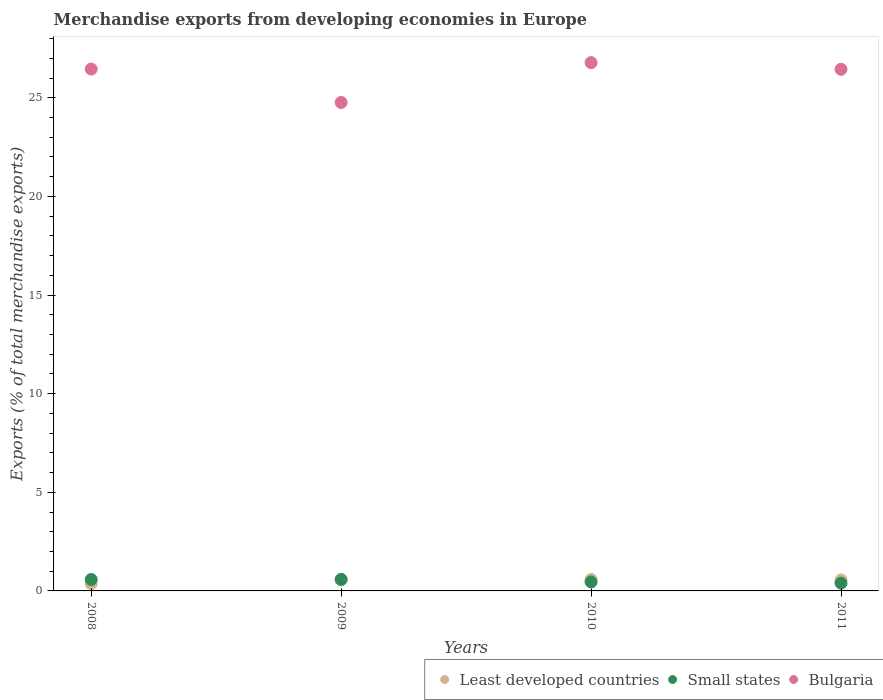How many different coloured dotlines are there?
Offer a very short reply. 3. What is the percentage of total merchandise exports in Small states in 2009?
Provide a short and direct response. 0.58. Across all years, what is the maximum percentage of total merchandise exports in Small states?
Offer a very short reply. 0.58. Across all years, what is the minimum percentage of total merchandise exports in Small states?
Ensure brevity in your answer.  0.39. In which year was the percentage of total merchandise exports in Least developed countries maximum?
Your response must be concise. 2010. In which year was the percentage of total merchandise exports in Bulgaria minimum?
Your answer should be very brief. 2009. What is the total percentage of total merchandise exports in Small states in the graph?
Your answer should be compact. 2.01. What is the difference between the percentage of total merchandise exports in Small states in 2009 and that in 2010?
Ensure brevity in your answer.  0.13. What is the difference between the percentage of total merchandise exports in Small states in 2008 and the percentage of total merchandise exports in Bulgaria in 2010?
Offer a very short reply. -26.2. What is the average percentage of total merchandise exports in Least developed countries per year?
Make the answer very short. 0.52. In the year 2009, what is the difference between the percentage of total merchandise exports in Bulgaria and percentage of total merchandise exports in Small states?
Provide a short and direct response. 24.18. What is the ratio of the percentage of total merchandise exports in Least developed countries in 2009 to that in 2011?
Make the answer very short. 1.02. What is the difference between the highest and the second highest percentage of total merchandise exports in Small states?
Make the answer very short. 0. What is the difference between the highest and the lowest percentage of total merchandise exports in Bulgaria?
Your answer should be very brief. 2.02. Is the sum of the percentage of total merchandise exports in Small states in 2009 and 2010 greater than the maximum percentage of total merchandise exports in Bulgaria across all years?
Your response must be concise. No. Is the percentage of total merchandise exports in Small states strictly greater than the percentage of total merchandise exports in Least developed countries over the years?
Your answer should be compact. No. How many years are there in the graph?
Offer a very short reply. 4. What is the difference between two consecutive major ticks on the Y-axis?
Give a very brief answer. 5. Are the values on the major ticks of Y-axis written in scientific E-notation?
Ensure brevity in your answer.  No. Where does the legend appear in the graph?
Ensure brevity in your answer.  Bottom right. How many legend labels are there?
Offer a very short reply. 3. How are the legend labels stacked?
Offer a very short reply. Horizontal. What is the title of the graph?
Offer a terse response. Merchandise exports from developing economies in Europe. What is the label or title of the Y-axis?
Your response must be concise. Exports (% of total merchandise exports). What is the Exports (% of total merchandise exports) of Least developed countries in 2008?
Your answer should be very brief. 0.37. What is the Exports (% of total merchandise exports) of Small states in 2008?
Make the answer very short. 0.58. What is the Exports (% of total merchandise exports) in Bulgaria in 2008?
Your answer should be very brief. 26.46. What is the Exports (% of total merchandise exports) in Least developed countries in 2009?
Your response must be concise. 0.57. What is the Exports (% of total merchandise exports) in Small states in 2009?
Provide a short and direct response. 0.58. What is the Exports (% of total merchandise exports) in Bulgaria in 2009?
Ensure brevity in your answer.  24.76. What is the Exports (% of total merchandise exports) in Least developed countries in 2010?
Your response must be concise. 0.58. What is the Exports (% of total merchandise exports) in Small states in 2010?
Make the answer very short. 0.46. What is the Exports (% of total merchandise exports) in Bulgaria in 2010?
Keep it short and to the point. 26.78. What is the Exports (% of total merchandise exports) of Least developed countries in 2011?
Make the answer very short. 0.56. What is the Exports (% of total merchandise exports) in Small states in 2011?
Your answer should be very brief. 0.39. What is the Exports (% of total merchandise exports) in Bulgaria in 2011?
Offer a very short reply. 26.44. Across all years, what is the maximum Exports (% of total merchandise exports) in Least developed countries?
Your answer should be compact. 0.58. Across all years, what is the maximum Exports (% of total merchandise exports) of Small states?
Offer a terse response. 0.58. Across all years, what is the maximum Exports (% of total merchandise exports) of Bulgaria?
Offer a very short reply. 26.78. Across all years, what is the minimum Exports (% of total merchandise exports) of Least developed countries?
Your response must be concise. 0.37. Across all years, what is the minimum Exports (% of total merchandise exports) of Small states?
Give a very brief answer. 0.39. Across all years, what is the minimum Exports (% of total merchandise exports) of Bulgaria?
Offer a terse response. 24.76. What is the total Exports (% of total merchandise exports) of Least developed countries in the graph?
Provide a succinct answer. 2.07. What is the total Exports (% of total merchandise exports) of Small states in the graph?
Offer a very short reply. 2.01. What is the total Exports (% of total merchandise exports) of Bulgaria in the graph?
Provide a succinct answer. 104.44. What is the difference between the Exports (% of total merchandise exports) in Least developed countries in 2008 and that in 2009?
Ensure brevity in your answer.  -0.2. What is the difference between the Exports (% of total merchandise exports) in Small states in 2008 and that in 2009?
Your answer should be very brief. -0. What is the difference between the Exports (% of total merchandise exports) in Bulgaria in 2008 and that in 2009?
Ensure brevity in your answer.  1.69. What is the difference between the Exports (% of total merchandise exports) in Least developed countries in 2008 and that in 2010?
Offer a very short reply. -0.21. What is the difference between the Exports (% of total merchandise exports) of Small states in 2008 and that in 2010?
Your answer should be compact. 0.12. What is the difference between the Exports (% of total merchandise exports) in Bulgaria in 2008 and that in 2010?
Offer a very short reply. -0.33. What is the difference between the Exports (% of total merchandise exports) in Least developed countries in 2008 and that in 2011?
Provide a short and direct response. -0.19. What is the difference between the Exports (% of total merchandise exports) of Small states in 2008 and that in 2011?
Your response must be concise. 0.18. What is the difference between the Exports (% of total merchandise exports) of Bulgaria in 2008 and that in 2011?
Ensure brevity in your answer.  0.01. What is the difference between the Exports (% of total merchandise exports) in Least developed countries in 2009 and that in 2010?
Keep it short and to the point. -0.01. What is the difference between the Exports (% of total merchandise exports) of Small states in 2009 and that in 2010?
Your response must be concise. 0.13. What is the difference between the Exports (% of total merchandise exports) of Bulgaria in 2009 and that in 2010?
Give a very brief answer. -2.02. What is the difference between the Exports (% of total merchandise exports) of Least developed countries in 2009 and that in 2011?
Provide a short and direct response. 0.01. What is the difference between the Exports (% of total merchandise exports) of Small states in 2009 and that in 2011?
Ensure brevity in your answer.  0.19. What is the difference between the Exports (% of total merchandise exports) in Bulgaria in 2009 and that in 2011?
Ensure brevity in your answer.  -1.68. What is the difference between the Exports (% of total merchandise exports) of Least developed countries in 2010 and that in 2011?
Your answer should be compact. 0.02. What is the difference between the Exports (% of total merchandise exports) in Small states in 2010 and that in 2011?
Give a very brief answer. 0.06. What is the difference between the Exports (% of total merchandise exports) in Bulgaria in 2010 and that in 2011?
Give a very brief answer. 0.34. What is the difference between the Exports (% of total merchandise exports) in Least developed countries in 2008 and the Exports (% of total merchandise exports) in Small states in 2009?
Provide a succinct answer. -0.22. What is the difference between the Exports (% of total merchandise exports) in Least developed countries in 2008 and the Exports (% of total merchandise exports) in Bulgaria in 2009?
Keep it short and to the point. -24.4. What is the difference between the Exports (% of total merchandise exports) of Small states in 2008 and the Exports (% of total merchandise exports) of Bulgaria in 2009?
Give a very brief answer. -24.18. What is the difference between the Exports (% of total merchandise exports) in Least developed countries in 2008 and the Exports (% of total merchandise exports) in Small states in 2010?
Ensure brevity in your answer.  -0.09. What is the difference between the Exports (% of total merchandise exports) in Least developed countries in 2008 and the Exports (% of total merchandise exports) in Bulgaria in 2010?
Keep it short and to the point. -26.41. What is the difference between the Exports (% of total merchandise exports) in Small states in 2008 and the Exports (% of total merchandise exports) in Bulgaria in 2010?
Offer a terse response. -26.2. What is the difference between the Exports (% of total merchandise exports) in Least developed countries in 2008 and the Exports (% of total merchandise exports) in Small states in 2011?
Offer a terse response. -0.03. What is the difference between the Exports (% of total merchandise exports) in Least developed countries in 2008 and the Exports (% of total merchandise exports) in Bulgaria in 2011?
Keep it short and to the point. -26.08. What is the difference between the Exports (% of total merchandise exports) in Small states in 2008 and the Exports (% of total merchandise exports) in Bulgaria in 2011?
Your answer should be compact. -25.87. What is the difference between the Exports (% of total merchandise exports) of Least developed countries in 2009 and the Exports (% of total merchandise exports) of Small states in 2010?
Your response must be concise. 0.11. What is the difference between the Exports (% of total merchandise exports) of Least developed countries in 2009 and the Exports (% of total merchandise exports) of Bulgaria in 2010?
Your answer should be compact. -26.21. What is the difference between the Exports (% of total merchandise exports) in Small states in 2009 and the Exports (% of total merchandise exports) in Bulgaria in 2010?
Provide a succinct answer. -26.2. What is the difference between the Exports (% of total merchandise exports) of Least developed countries in 2009 and the Exports (% of total merchandise exports) of Small states in 2011?
Offer a very short reply. 0.17. What is the difference between the Exports (% of total merchandise exports) of Least developed countries in 2009 and the Exports (% of total merchandise exports) of Bulgaria in 2011?
Offer a very short reply. -25.88. What is the difference between the Exports (% of total merchandise exports) in Small states in 2009 and the Exports (% of total merchandise exports) in Bulgaria in 2011?
Keep it short and to the point. -25.86. What is the difference between the Exports (% of total merchandise exports) of Least developed countries in 2010 and the Exports (% of total merchandise exports) of Small states in 2011?
Offer a very short reply. 0.18. What is the difference between the Exports (% of total merchandise exports) in Least developed countries in 2010 and the Exports (% of total merchandise exports) in Bulgaria in 2011?
Keep it short and to the point. -25.87. What is the difference between the Exports (% of total merchandise exports) of Small states in 2010 and the Exports (% of total merchandise exports) of Bulgaria in 2011?
Offer a terse response. -25.99. What is the average Exports (% of total merchandise exports) of Least developed countries per year?
Provide a short and direct response. 0.52. What is the average Exports (% of total merchandise exports) of Small states per year?
Provide a succinct answer. 0.5. What is the average Exports (% of total merchandise exports) of Bulgaria per year?
Give a very brief answer. 26.11. In the year 2008, what is the difference between the Exports (% of total merchandise exports) in Least developed countries and Exports (% of total merchandise exports) in Small states?
Give a very brief answer. -0.21. In the year 2008, what is the difference between the Exports (% of total merchandise exports) in Least developed countries and Exports (% of total merchandise exports) in Bulgaria?
Offer a terse response. -26.09. In the year 2008, what is the difference between the Exports (% of total merchandise exports) of Small states and Exports (% of total merchandise exports) of Bulgaria?
Your answer should be compact. -25.88. In the year 2009, what is the difference between the Exports (% of total merchandise exports) of Least developed countries and Exports (% of total merchandise exports) of Small states?
Give a very brief answer. -0.01. In the year 2009, what is the difference between the Exports (% of total merchandise exports) in Least developed countries and Exports (% of total merchandise exports) in Bulgaria?
Make the answer very short. -24.19. In the year 2009, what is the difference between the Exports (% of total merchandise exports) in Small states and Exports (% of total merchandise exports) in Bulgaria?
Your response must be concise. -24.18. In the year 2010, what is the difference between the Exports (% of total merchandise exports) in Least developed countries and Exports (% of total merchandise exports) in Small states?
Provide a short and direct response. 0.12. In the year 2010, what is the difference between the Exports (% of total merchandise exports) of Least developed countries and Exports (% of total merchandise exports) of Bulgaria?
Offer a very short reply. -26.2. In the year 2010, what is the difference between the Exports (% of total merchandise exports) of Small states and Exports (% of total merchandise exports) of Bulgaria?
Offer a very short reply. -26.33. In the year 2011, what is the difference between the Exports (% of total merchandise exports) of Least developed countries and Exports (% of total merchandise exports) of Small states?
Offer a terse response. 0.16. In the year 2011, what is the difference between the Exports (% of total merchandise exports) of Least developed countries and Exports (% of total merchandise exports) of Bulgaria?
Your answer should be very brief. -25.89. In the year 2011, what is the difference between the Exports (% of total merchandise exports) of Small states and Exports (% of total merchandise exports) of Bulgaria?
Give a very brief answer. -26.05. What is the ratio of the Exports (% of total merchandise exports) of Least developed countries in 2008 to that in 2009?
Your answer should be very brief. 0.64. What is the ratio of the Exports (% of total merchandise exports) in Small states in 2008 to that in 2009?
Ensure brevity in your answer.  0.99. What is the ratio of the Exports (% of total merchandise exports) in Bulgaria in 2008 to that in 2009?
Make the answer very short. 1.07. What is the ratio of the Exports (% of total merchandise exports) in Least developed countries in 2008 to that in 2010?
Offer a terse response. 0.63. What is the ratio of the Exports (% of total merchandise exports) in Small states in 2008 to that in 2010?
Make the answer very short. 1.27. What is the ratio of the Exports (% of total merchandise exports) of Bulgaria in 2008 to that in 2010?
Offer a very short reply. 0.99. What is the ratio of the Exports (% of total merchandise exports) of Least developed countries in 2008 to that in 2011?
Your response must be concise. 0.66. What is the ratio of the Exports (% of total merchandise exports) of Small states in 2008 to that in 2011?
Offer a terse response. 1.47. What is the ratio of the Exports (% of total merchandise exports) in Bulgaria in 2008 to that in 2011?
Provide a short and direct response. 1. What is the ratio of the Exports (% of total merchandise exports) in Least developed countries in 2009 to that in 2010?
Your answer should be very brief. 0.98. What is the ratio of the Exports (% of total merchandise exports) of Small states in 2009 to that in 2010?
Give a very brief answer. 1.28. What is the ratio of the Exports (% of total merchandise exports) of Bulgaria in 2009 to that in 2010?
Ensure brevity in your answer.  0.92. What is the ratio of the Exports (% of total merchandise exports) of Least developed countries in 2009 to that in 2011?
Make the answer very short. 1.02. What is the ratio of the Exports (% of total merchandise exports) in Small states in 2009 to that in 2011?
Your answer should be compact. 1.48. What is the ratio of the Exports (% of total merchandise exports) of Bulgaria in 2009 to that in 2011?
Ensure brevity in your answer.  0.94. What is the ratio of the Exports (% of total merchandise exports) in Least developed countries in 2010 to that in 2011?
Ensure brevity in your answer.  1.04. What is the ratio of the Exports (% of total merchandise exports) in Small states in 2010 to that in 2011?
Offer a very short reply. 1.16. What is the ratio of the Exports (% of total merchandise exports) of Bulgaria in 2010 to that in 2011?
Provide a short and direct response. 1.01. What is the difference between the highest and the second highest Exports (% of total merchandise exports) in Least developed countries?
Offer a terse response. 0.01. What is the difference between the highest and the second highest Exports (% of total merchandise exports) in Small states?
Your answer should be very brief. 0. What is the difference between the highest and the second highest Exports (% of total merchandise exports) of Bulgaria?
Your answer should be compact. 0.33. What is the difference between the highest and the lowest Exports (% of total merchandise exports) of Least developed countries?
Your answer should be very brief. 0.21. What is the difference between the highest and the lowest Exports (% of total merchandise exports) of Small states?
Make the answer very short. 0.19. What is the difference between the highest and the lowest Exports (% of total merchandise exports) in Bulgaria?
Your answer should be very brief. 2.02. 